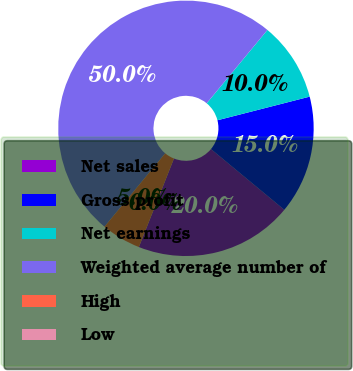<chart> <loc_0><loc_0><loc_500><loc_500><pie_chart><fcel>Net sales<fcel>Gross profit<fcel>Net earnings<fcel>Weighted average number of<fcel>High<fcel>Low<nl><fcel>20.0%<fcel>15.0%<fcel>10.0%<fcel>50.0%<fcel>5.0%<fcel>0.0%<nl></chart> 